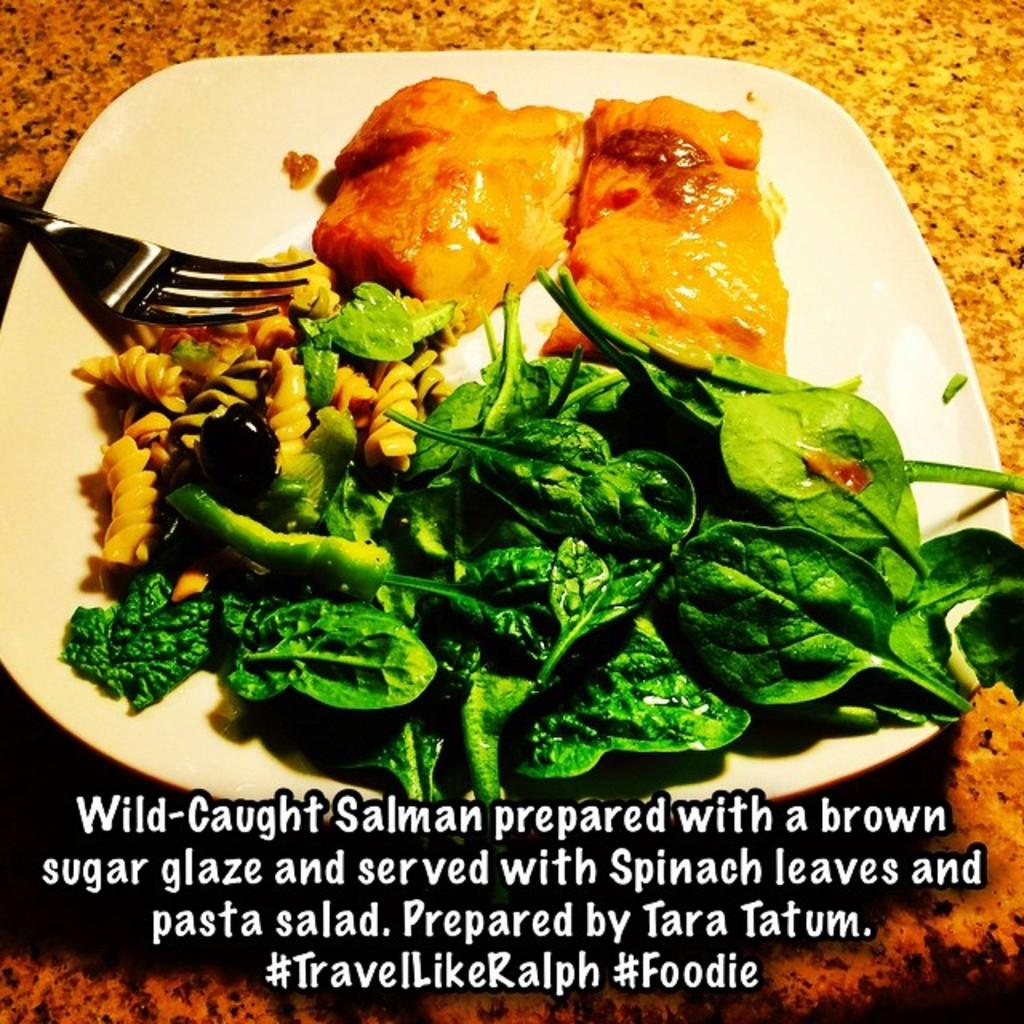What piece of furniture is present in the image? There is a table in the image. What is on the table? There is a plate containing food and a fork placed on the table. Where can the text be found in the image? The text is at the bottom of the image. Is there a patch of water visible on the table in the image? No, there is no patch of water visible on the table in the image. 